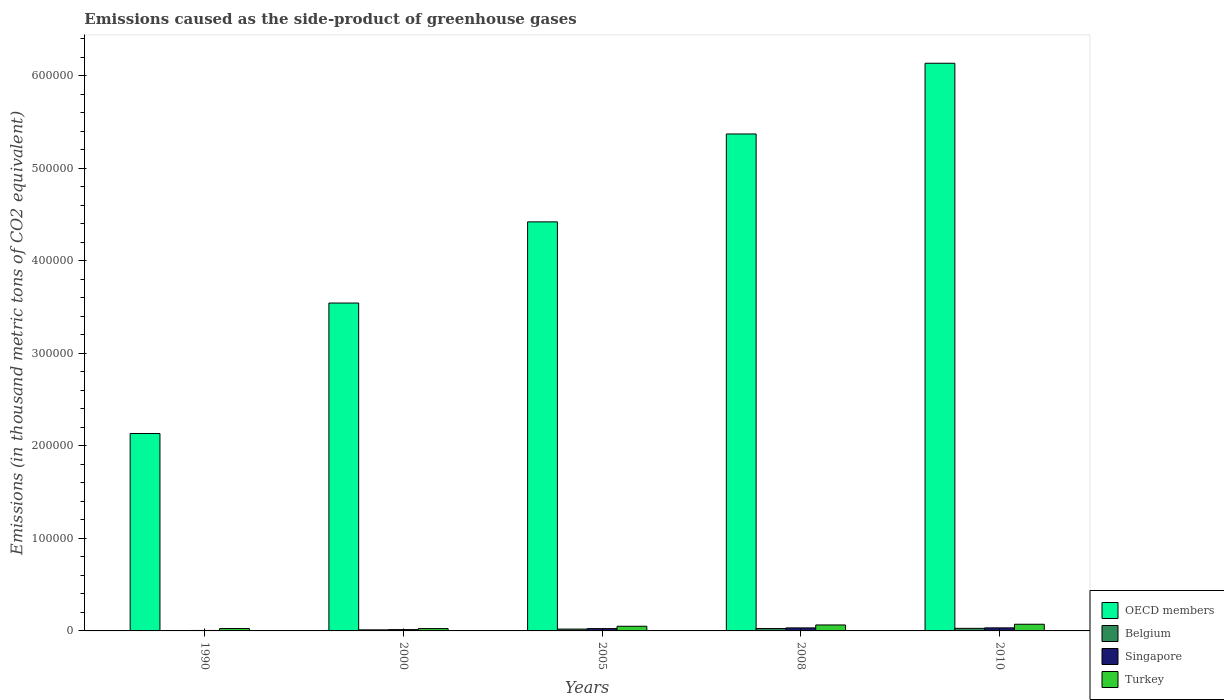How many different coloured bars are there?
Your answer should be very brief. 4. How many groups of bars are there?
Offer a terse response. 5. Are the number of bars on each tick of the X-axis equal?
Your answer should be compact. Yes. How many bars are there on the 5th tick from the left?
Keep it short and to the point. 4. How many bars are there on the 1st tick from the right?
Your answer should be very brief. 4. In how many cases, is the number of bars for a given year not equal to the number of legend labels?
Keep it short and to the point. 0. What is the emissions caused as the side-product of greenhouse gases in Singapore in 2008?
Provide a short and direct response. 3266.4. Across all years, what is the maximum emissions caused as the side-product of greenhouse gases in Singapore?
Offer a terse response. 3296. Across all years, what is the minimum emissions caused as the side-product of greenhouse gases in OECD members?
Keep it short and to the point. 2.13e+05. In which year was the emissions caused as the side-product of greenhouse gases in Belgium maximum?
Provide a succinct answer. 2010. In which year was the emissions caused as the side-product of greenhouse gases in Singapore minimum?
Offer a very short reply. 1990. What is the total emissions caused as the side-product of greenhouse gases in Belgium in the graph?
Offer a very short reply. 8631.7. What is the difference between the emissions caused as the side-product of greenhouse gases in Belgium in 2005 and that in 2010?
Make the answer very short. -794.8. What is the difference between the emissions caused as the side-product of greenhouse gases in Turkey in 2005 and the emissions caused as the side-product of greenhouse gases in Singapore in 1990?
Offer a very short reply. 4539.8. What is the average emissions caused as the side-product of greenhouse gases in OECD members per year?
Provide a short and direct response. 4.32e+05. In the year 2005, what is the difference between the emissions caused as the side-product of greenhouse gases in Turkey and emissions caused as the side-product of greenhouse gases in OECD members?
Make the answer very short. -4.37e+05. In how many years, is the emissions caused as the side-product of greenhouse gases in Turkey greater than 80000 thousand metric tons?
Ensure brevity in your answer.  0. What is the ratio of the emissions caused as the side-product of greenhouse gases in Turkey in 2008 to that in 2010?
Offer a very short reply. 0.89. Is the difference between the emissions caused as the side-product of greenhouse gases in Turkey in 2005 and 2010 greater than the difference between the emissions caused as the side-product of greenhouse gases in OECD members in 2005 and 2010?
Offer a terse response. Yes. What is the difference between the highest and the second highest emissions caused as the side-product of greenhouse gases in Turkey?
Your answer should be very brief. 775. What is the difference between the highest and the lowest emissions caused as the side-product of greenhouse gases in Belgium?
Your response must be concise. 2634.1. In how many years, is the emissions caused as the side-product of greenhouse gases in Turkey greater than the average emissions caused as the side-product of greenhouse gases in Turkey taken over all years?
Your answer should be compact. 3. Is the sum of the emissions caused as the side-product of greenhouse gases in Turkey in 2000 and 2008 greater than the maximum emissions caused as the side-product of greenhouse gases in Belgium across all years?
Offer a terse response. Yes. What does the 2nd bar from the left in 2005 represents?
Ensure brevity in your answer.  Belgium. What does the 3rd bar from the right in 2000 represents?
Provide a succinct answer. Belgium. How many years are there in the graph?
Keep it short and to the point. 5. What is the difference between two consecutive major ticks on the Y-axis?
Your answer should be very brief. 1.00e+05. Are the values on the major ticks of Y-axis written in scientific E-notation?
Your answer should be compact. No. Does the graph contain any zero values?
Make the answer very short. No. How are the legend labels stacked?
Offer a very short reply. Vertical. What is the title of the graph?
Your response must be concise. Emissions caused as the side-product of greenhouse gases. Does "Low income" appear as one of the legend labels in the graph?
Offer a very short reply. No. What is the label or title of the Y-axis?
Offer a terse response. Emissions (in thousand metric tons of CO2 equivalent). What is the Emissions (in thousand metric tons of CO2 equivalent) of OECD members in 1990?
Your answer should be very brief. 2.13e+05. What is the Emissions (in thousand metric tons of CO2 equivalent) of Belgium in 1990?
Offer a very short reply. 141.9. What is the Emissions (in thousand metric tons of CO2 equivalent) in Singapore in 1990?
Offer a very short reply. 501.5. What is the Emissions (in thousand metric tons of CO2 equivalent) in Turkey in 1990?
Keep it short and to the point. 2572.7. What is the Emissions (in thousand metric tons of CO2 equivalent) of OECD members in 2000?
Offer a very short reply. 3.54e+05. What is the Emissions (in thousand metric tons of CO2 equivalent) of Belgium in 2000?
Provide a succinct answer. 1154.6. What is the Emissions (in thousand metric tons of CO2 equivalent) in Singapore in 2000?
Your answer should be compact. 1409.6. What is the Emissions (in thousand metric tons of CO2 equivalent) of Turkey in 2000?
Your answer should be very brief. 2538.5. What is the Emissions (in thousand metric tons of CO2 equivalent) in OECD members in 2005?
Keep it short and to the point. 4.42e+05. What is the Emissions (in thousand metric tons of CO2 equivalent) in Belgium in 2005?
Offer a very short reply. 1981.2. What is the Emissions (in thousand metric tons of CO2 equivalent) of Singapore in 2005?
Make the answer very short. 2496.4. What is the Emissions (in thousand metric tons of CO2 equivalent) of Turkey in 2005?
Give a very brief answer. 5041.3. What is the Emissions (in thousand metric tons of CO2 equivalent) of OECD members in 2008?
Your answer should be very brief. 5.37e+05. What is the Emissions (in thousand metric tons of CO2 equivalent) of Belgium in 2008?
Offer a terse response. 2578. What is the Emissions (in thousand metric tons of CO2 equivalent) of Singapore in 2008?
Keep it short and to the point. 3266.4. What is the Emissions (in thousand metric tons of CO2 equivalent) in Turkey in 2008?
Ensure brevity in your answer.  6441. What is the Emissions (in thousand metric tons of CO2 equivalent) in OECD members in 2010?
Make the answer very short. 6.14e+05. What is the Emissions (in thousand metric tons of CO2 equivalent) in Belgium in 2010?
Make the answer very short. 2776. What is the Emissions (in thousand metric tons of CO2 equivalent) in Singapore in 2010?
Provide a short and direct response. 3296. What is the Emissions (in thousand metric tons of CO2 equivalent) of Turkey in 2010?
Offer a very short reply. 7216. Across all years, what is the maximum Emissions (in thousand metric tons of CO2 equivalent) of OECD members?
Your answer should be compact. 6.14e+05. Across all years, what is the maximum Emissions (in thousand metric tons of CO2 equivalent) in Belgium?
Provide a short and direct response. 2776. Across all years, what is the maximum Emissions (in thousand metric tons of CO2 equivalent) in Singapore?
Provide a succinct answer. 3296. Across all years, what is the maximum Emissions (in thousand metric tons of CO2 equivalent) in Turkey?
Make the answer very short. 7216. Across all years, what is the minimum Emissions (in thousand metric tons of CO2 equivalent) in OECD members?
Provide a short and direct response. 2.13e+05. Across all years, what is the minimum Emissions (in thousand metric tons of CO2 equivalent) of Belgium?
Your answer should be very brief. 141.9. Across all years, what is the minimum Emissions (in thousand metric tons of CO2 equivalent) in Singapore?
Provide a short and direct response. 501.5. Across all years, what is the minimum Emissions (in thousand metric tons of CO2 equivalent) of Turkey?
Provide a short and direct response. 2538.5. What is the total Emissions (in thousand metric tons of CO2 equivalent) of OECD members in the graph?
Keep it short and to the point. 2.16e+06. What is the total Emissions (in thousand metric tons of CO2 equivalent) in Belgium in the graph?
Offer a very short reply. 8631.7. What is the total Emissions (in thousand metric tons of CO2 equivalent) in Singapore in the graph?
Make the answer very short. 1.10e+04. What is the total Emissions (in thousand metric tons of CO2 equivalent) of Turkey in the graph?
Provide a succinct answer. 2.38e+04. What is the difference between the Emissions (in thousand metric tons of CO2 equivalent) in OECD members in 1990 and that in 2000?
Keep it short and to the point. -1.41e+05. What is the difference between the Emissions (in thousand metric tons of CO2 equivalent) in Belgium in 1990 and that in 2000?
Offer a terse response. -1012.7. What is the difference between the Emissions (in thousand metric tons of CO2 equivalent) in Singapore in 1990 and that in 2000?
Ensure brevity in your answer.  -908.1. What is the difference between the Emissions (in thousand metric tons of CO2 equivalent) of Turkey in 1990 and that in 2000?
Provide a short and direct response. 34.2. What is the difference between the Emissions (in thousand metric tons of CO2 equivalent) of OECD members in 1990 and that in 2005?
Ensure brevity in your answer.  -2.29e+05. What is the difference between the Emissions (in thousand metric tons of CO2 equivalent) of Belgium in 1990 and that in 2005?
Your answer should be compact. -1839.3. What is the difference between the Emissions (in thousand metric tons of CO2 equivalent) of Singapore in 1990 and that in 2005?
Keep it short and to the point. -1994.9. What is the difference between the Emissions (in thousand metric tons of CO2 equivalent) in Turkey in 1990 and that in 2005?
Offer a terse response. -2468.6. What is the difference between the Emissions (in thousand metric tons of CO2 equivalent) in OECD members in 1990 and that in 2008?
Make the answer very short. -3.24e+05. What is the difference between the Emissions (in thousand metric tons of CO2 equivalent) of Belgium in 1990 and that in 2008?
Offer a very short reply. -2436.1. What is the difference between the Emissions (in thousand metric tons of CO2 equivalent) in Singapore in 1990 and that in 2008?
Your answer should be very brief. -2764.9. What is the difference between the Emissions (in thousand metric tons of CO2 equivalent) in Turkey in 1990 and that in 2008?
Provide a short and direct response. -3868.3. What is the difference between the Emissions (in thousand metric tons of CO2 equivalent) in OECD members in 1990 and that in 2010?
Offer a terse response. -4.00e+05. What is the difference between the Emissions (in thousand metric tons of CO2 equivalent) of Belgium in 1990 and that in 2010?
Ensure brevity in your answer.  -2634.1. What is the difference between the Emissions (in thousand metric tons of CO2 equivalent) of Singapore in 1990 and that in 2010?
Your answer should be very brief. -2794.5. What is the difference between the Emissions (in thousand metric tons of CO2 equivalent) in Turkey in 1990 and that in 2010?
Offer a very short reply. -4643.3. What is the difference between the Emissions (in thousand metric tons of CO2 equivalent) of OECD members in 2000 and that in 2005?
Make the answer very short. -8.78e+04. What is the difference between the Emissions (in thousand metric tons of CO2 equivalent) of Belgium in 2000 and that in 2005?
Provide a short and direct response. -826.6. What is the difference between the Emissions (in thousand metric tons of CO2 equivalent) in Singapore in 2000 and that in 2005?
Offer a very short reply. -1086.8. What is the difference between the Emissions (in thousand metric tons of CO2 equivalent) of Turkey in 2000 and that in 2005?
Ensure brevity in your answer.  -2502.8. What is the difference between the Emissions (in thousand metric tons of CO2 equivalent) of OECD members in 2000 and that in 2008?
Give a very brief answer. -1.83e+05. What is the difference between the Emissions (in thousand metric tons of CO2 equivalent) in Belgium in 2000 and that in 2008?
Give a very brief answer. -1423.4. What is the difference between the Emissions (in thousand metric tons of CO2 equivalent) in Singapore in 2000 and that in 2008?
Your response must be concise. -1856.8. What is the difference between the Emissions (in thousand metric tons of CO2 equivalent) of Turkey in 2000 and that in 2008?
Your response must be concise. -3902.5. What is the difference between the Emissions (in thousand metric tons of CO2 equivalent) in OECD members in 2000 and that in 2010?
Your response must be concise. -2.59e+05. What is the difference between the Emissions (in thousand metric tons of CO2 equivalent) in Belgium in 2000 and that in 2010?
Keep it short and to the point. -1621.4. What is the difference between the Emissions (in thousand metric tons of CO2 equivalent) in Singapore in 2000 and that in 2010?
Give a very brief answer. -1886.4. What is the difference between the Emissions (in thousand metric tons of CO2 equivalent) of Turkey in 2000 and that in 2010?
Your response must be concise. -4677.5. What is the difference between the Emissions (in thousand metric tons of CO2 equivalent) in OECD members in 2005 and that in 2008?
Make the answer very short. -9.50e+04. What is the difference between the Emissions (in thousand metric tons of CO2 equivalent) of Belgium in 2005 and that in 2008?
Keep it short and to the point. -596.8. What is the difference between the Emissions (in thousand metric tons of CO2 equivalent) in Singapore in 2005 and that in 2008?
Your answer should be compact. -770. What is the difference between the Emissions (in thousand metric tons of CO2 equivalent) of Turkey in 2005 and that in 2008?
Ensure brevity in your answer.  -1399.7. What is the difference between the Emissions (in thousand metric tons of CO2 equivalent) in OECD members in 2005 and that in 2010?
Provide a succinct answer. -1.71e+05. What is the difference between the Emissions (in thousand metric tons of CO2 equivalent) of Belgium in 2005 and that in 2010?
Your answer should be very brief. -794.8. What is the difference between the Emissions (in thousand metric tons of CO2 equivalent) in Singapore in 2005 and that in 2010?
Make the answer very short. -799.6. What is the difference between the Emissions (in thousand metric tons of CO2 equivalent) of Turkey in 2005 and that in 2010?
Provide a short and direct response. -2174.7. What is the difference between the Emissions (in thousand metric tons of CO2 equivalent) in OECD members in 2008 and that in 2010?
Give a very brief answer. -7.65e+04. What is the difference between the Emissions (in thousand metric tons of CO2 equivalent) of Belgium in 2008 and that in 2010?
Keep it short and to the point. -198. What is the difference between the Emissions (in thousand metric tons of CO2 equivalent) in Singapore in 2008 and that in 2010?
Offer a very short reply. -29.6. What is the difference between the Emissions (in thousand metric tons of CO2 equivalent) of Turkey in 2008 and that in 2010?
Your answer should be compact. -775. What is the difference between the Emissions (in thousand metric tons of CO2 equivalent) of OECD members in 1990 and the Emissions (in thousand metric tons of CO2 equivalent) of Belgium in 2000?
Offer a very short reply. 2.12e+05. What is the difference between the Emissions (in thousand metric tons of CO2 equivalent) in OECD members in 1990 and the Emissions (in thousand metric tons of CO2 equivalent) in Singapore in 2000?
Offer a terse response. 2.12e+05. What is the difference between the Emissions (in thousand metric tons of CO2 equivalent) in OECD members in 1990 and the Emissions (in thousand metric tons of CO2 equivalent) in Turkey in 2000?
Offer a terse response. 2.11e+05. What is the difference between the Emissions (in thousand metric tons of CO2 equivalent) in Belgium in 1990 and the Emissions (in thousand metric tons of CO2 equivalent) in Singapore in 2000?
Offer a terse response. -1267.7. What is the difference between the Emissions (in thousand metric tons of CO2 equivalent) in Belgium in 1990 and the Emissions (in thousand metric tons of CO2 equivalent) in Turkey in 2000?
Offer a terse response. -2396.6. What is the difference between the Emissions (in thousand metric tons of CO2 equivalent) of Singapore in 1990 and the Emissions (in thousand metric tons of CO2 equivalent) of Turkey in 2000?
Ensure brevity in your answer.  -2037. What is the difference between the Emissions (in thousand metric tons of CO2 equivalent) in OECD members in 1990 and the Emissions (in thousand metric tons of CO2 equivalent) in Belgium in 2005?
Provide a succinct answer. 2.11e+05. What is the difference between the Emissions (in thousand metric tons of CO2 equivalent) of OECD members in 1990 and the Emissions (in thousand metric tons of CO2 equivalent) of Singapore in 2005?
Give a very brief answer. 2.11e+05. What is the difference between the Emissions (in thousand metric tons of CO2 equivalent) in OECD members in 1990 and the Emissions (in thousand metric tons of CO2 equivalent) in Turkey in 2005?
Your response must be concise. 2.08e+05. What is the difference between the Emissions (in thousand metric tons of CO2 equivalent) in Belgium in 1990 and the Emissions (in thousand metric tons of CO2 equivalent) in Singapore in 2005?
Give a very brief answer. -2354.5. What is the difference between the Emissions (in thousand metric tons of CO2 equivalent) in Belgium in 1990 and the Emissions (in thousand metric tons of CO2 equivalent) in Turkey in 2005?
Make the answer very short. -4899.4. What is the difference between the Emissions (in thousand metric tons of CO2 equivalent) of Singapore in 1990 and the Emissions (in thousand metric tons of CO2 equivalent) of Turkey in 2005?
Give a very brief answer. -4539.8. What is the difference between the Emissions (in thousand metric tons of CO2 equivalent) of OECD members in 1990 and the Emissions (in thousand metric tons of CO2 equivalent) of Belgium in 2008?
Offer a very short reply. 2.11e+05. What is the difference between the Emissions (in thousand metric tons of CO2 equivalent) of OECD members in 1990 and the Emissions (in thousand metric tons of CO2 equivalent) of Singapore in 2008?
Your answer should be very brief. 2.10e+05. What is the difference between the Emissions (in thousand metric tons of CO2 equivalent) of OECD members in 1990 and the Emissions (in thousand metric tons of CO2 equivalent) of Turkey in 2008?
Keep it short and to the point. 2.07e+05. What is the difference between the Emissions (in thousand metric tons of CO2 equivalent) of Belgium in 1990 and the Emissions (in thousand metric tons of CO2 equivalent) of Singapore in 2008?
Provide a succinct answer. -3124.5. What is the difference between the Emissions (in thousand metric tons of CO2 equivalent) of Belgium in 1990 and the Emissions (in thousand metric tons of CO2 equivalent) of Turkey in 2008?
Provide a short and direct response. -6299.1. What is the difference between the Emissions (in thousand metric tons of CO2 equivalent) in Singapore in 1990 and the Emissions (in thousand metric tons of CO2 equivalent) in Turkey in 2008?
Make the answer very short. -5939.5. What is the difference between the Emissions (in thousand metric tons of CO2 equivalent) of OECD members in 1990 and the Emissions (in thousand metric tons of CO2 equivalent) of Belgium in 2010?
Offer a very short reply. 2.11e+05. What is the difference between the Emissions (in thousand metric tons of CO2 equivalent) in OECD members in 1990 and the Emissions (in thousand metric tons of CO2 equivalent) in Singapore in 2010?
Your answer should be very brief. 2.10e+05. What is the difference between the Emissions (in thousand metric tons of CO2 equivalent) of OECD members in 1990 and the Emissions (in thousand metric tons of CO2 equivalent) of Turkey in 2010?
Your answer should be compact. 2.06e+05. What is the difference between the Emissions (in thousand metric tons of CO2 equivalent) in Belgium in 1990 and the Emissions (in thousand metric tons of CO2 equivalent) in Singapore in 2010?
Your answer should be compact. -3154.1. What is the difference between the Emissions (in thousand metric tons of CO2 equivalent) of Belgium in 1990 and the Emissions (in thousand metric tons of CO2 equivalent) of Turkey in 2010?
Give a very brief answer. -7074.1. What is the difference between the Emissions (in thousand metric tons of CO2 equivalent) of Singapore in 1990 and the Emissions (in thousand metric tons of CO2 equivalent) of Turkey in 2010?
Ensure brevity in your answer.  -6714.5. What is the difference between the Emissions (in thousand metric tons of CO2 equivalent) in OECD members in 2000 and the Emissions (in thousand metric tons of CO2 equivalent) in Belgium in 2005?
Offer a very short reply. 3.53e+05. What is the difference between the Emissions (in thousand metric tons of CO2 equivalent) in OECD members in 2000 and the Emissions (in thousand metric tons of CO2 equivalent) in Singapore in 2005?
Offer a very short reply. 3.52e+05. What is the difference between the Emissions (in thousand metric tons of CO2 equivalent) in OECD members in 2000 and the Emissions (in thousand metric tons of CO2 equivalent) in Turkey in 2005?
Give a very brief answer. 3.49e+05. What is the difference between the Emissions (in thousand metric tons of CO2 equivalent) of Belgium in 2000 and the Emissions (in thousand metric tons of CO2 equivalent) of Singapore in 2005?
Make the answer very short. -1341.8. What is the difference between the Emissions (in thousand metric tons of CO2 equivalent) of Belgium in 2000 and the Emissions (in thousand metric tons of CO2 equivalent) of Turkey in 2005?
Make the answer very short. -3886.7. What is the difference between the Emissions (in thousand metric tons of CO2 equivalent) in Singapore in 2000 and the Emissions (in thousand metric tons of CO2 equivalent) in Turkey in 2005?
Provide a succinct answer. -3631.7. What is the difference between the Emissions (in thousand metric tons of CO2 equivalent) of OECD members in 2000 and the Emissions (in thousand metric tons of CO2 equivalent) of Belgium in 2008?
Offer a terse response. 3.52e+05. What is the difference between the Emissions (in thousand metric tons of CO2 equivalent) in OECD members in 2000 and the Emissions (in thousand metric tons of CO2 equivalent) in Singapore in 2008?
Offer a terse response. 3.51e+05. What is the difference between the Emissions (in thousand metric tons of CO2 equivalent) in OECD members in 2000 and the Emissions (in thousand metric tons of CO2 equivalent) in Turkey in 2008?
Offer a terse response. 3.48e+05. What is the difference between the Emissions (in thousand metric tons of CO2 equivalent) in Belgium in 2000 and the Emissions (in thousand metric tons of CO2 equivalent) in Singapore in 2008?
Offer a very short reply. -2111.8. What is the difference between the Emissions (in thousand metric tons of CO2 equivalent) of Belgium in 2000 and the Emissions (in thousand metric tons of CO2 equivalent) of Turkey in 2008?
Your answer should be compact. -5286.4. What is the difference between the Emissions (in thousand metric tons of CO2 equivalent) in Singapore in 2000 and the Emissions (in thousand metric tons of CO2 equivalent) in Turkey in 2008?
Your answer should be compact. -5031.4. What is the difference between the Emissions (in thousand metric tons of CO2 equivalent) of OECD members in 2000 and the Emissions (in thousand metric tons of CO2 equivalent) of Belgium in 2010?
Ensure brevity in your answer.  3.52e+05. What is the difference between the Emissions (in thousand metric tons of CO2 equivalent) of OECD members in 2000 and the Emissions (in thousand metric tons of CO2 equivalent) of Singapore in 2010?
Give a very brief answer. 3.51e+05. What is the difference between the Emissions (in thousand metric tons of CO2 equivalent) of OECD members in 2000 and the Emissions (in thousand metric tons of CO2 equivalent) of Turkey in 2010?
Make the answer very short. 3.47e+05. What is the difference between the Emissions (in thousand metric tons of CO2 equivalent) in Belgium in 2000 and the Emissions (in thousand metric tons of CO2 equivalent) in Singapore in 2010?
Your answer should be very brief. -2141.4. What is the difference between the Emissions (in thousand metric tons of CO2 equivalent) of Belgium in 2000 and the Emissions (in thousand metric tons of CO2 equivalent) of Turkey in 2010?
Keep it short and to the point. -6061.4. What is the difference between the Emissions (in thousand metric tons of CO2 equivalent) of Singapore in 2000 and the Emissions (in thousand metric tons of CO2 equivalent) of Turkey in 2010?
Provide a short and direct response. -5806.4. What is the difference between the Emissions (in thousand metric tons of CO2 equivalent) in OECD members in 2005 and the Emissions (in thousand metric tons of CO2 equivalent) in Belgium in 2008?
Make the answer very short. 4.40e+05. What is the difference between the Emissions (in thousand metric tons of CO2 equivalent) of OECD members in 2005 and the Emissions (in thousand metric tons of CO2 equivalent) of Singapore in 2008?
Keep it short and to the point. 4.39e+05. What is the difference between the Emissions (in thousand metric tons of CO2 equivalent) of OECD members in 2005 and the Emissions (in thousand metric tons of CO2 equivalent) of Turkey in 2008?
Offer a terse response. 4.36e+05. What is the difference between the Emissions (in thousand metric tons of CO2 equivalent) of Belgium in 2005 and the Emissions (in thousand metric tons of CO2 equivalent) of Singapore in 2008?
Your answer should be compact. -1285.2. What is the difference between the Emissions (in thousand metric tons of CO2 equivalent) in Belgium in 2005 and the Emissions (in thousand metric tons of CO2 equivalent) in Turkey in 2008?
Provide a succinct answer. -4459.8. What is the difference between the Emissions (in thousand metric tons of CO2 equivalent) of Singapore in 2005 and the Emissions (in thousand metric tons of CO2 equivalent) of Turkey in 2008?
Your answer should be very brief. -3944.6. What is the difference between the Emissions (in thousand metric tons of CO2 equivalent) in OECD members in 2005 and the Emissions (in thousand metric tons of CO2 equivalent) in Belgium in 2010?
Your response must be concise. 4.39e+05. What is the difference between the Emissions (in thousand metric tons of CO2 equivalent) of OECD members in 2005 and the Emissions (in thousand metric tons of CO2 equivalent) of Singapore in 2010?
Make the answer very short. 4.39e+05. What is the difference between the Emissions (in thousand metric tons of CO2 equivalent) in OECD members in 2005 and the Emissions (in thousand metric tons of CO2 equivalent) in Turkey in 2010?
Keep it short and to the point. 4.35e+05. What is the difference between the Emissions (in thousand metric tons of CO2 equivalent) of Belgium in 2005 and the Emissions (in thousand metric tons of CO2 equivalent) of Singapore in 2010?
Keep it short and to the point. -1314.8. What is the difference between the Emissions (in thousand metric tons of CO2 equivalent) in Belgium in 2005 and the Emissions (in thousand metric tons of CO2 equivalent) in Turkey in 2010?
Your answer should be compact. -5234.8. What is the difference between the Emissions (in thousand metric tons of CO2 equivalent) of Singapore in 2005 and the Emissions (in thousand metric tons of CO2 equivalent) of Turkey in 2010?
Provide a succinct answer. -4719.6. What is the difference between the Emissions (in thousand metric tons of CO2 equivalent) in OECD members in 2008 and the Emissions (in thousand metric tons of CO2 equivalent) in Belgium in 2010?
Keep it short and to the point. 5.34e+05. What is the difference between the Emissions (in thousand metric tons of CO2 equivalent) of OECD members in 2008 and the Emissions (in thousand metric tons of CO2 equivalent) of Singapore in 2010?
Ensure brevity in your answer.  5.34e+05. What is the difference between the Emissions (in thousand metric tons of CO2 equivalent) in OECD members in 2008 and the Emissions (in thousand metric tons of CO2 equivalent) in Turkey in 2010?
Provide a succinct answer. 5.30e+05. What is the difference between the Emissions (in thousand metric tons of CO2 equivalent) in Belgium in 2008 and the Emissions (in thousand metric tons of CO2 equivalent) in Singapore in 2010?
Give a very brief answer. -718. What is the difference between the Emissions (in thousand metric tons of CO2 equivalent) in Belgium in 2008 and the Emissions (in thousand metric tons of CO2 equivalent) in Turkey in 2010?
Keep it short and to the point. -4638. What is the difference between the Emissions (in thousand metric tons of CO2 equivalent) of Singapore in 2008 and the Emissions (in thousand metric tons of CO2 equivalent) of Turkey in 2010?
Your answer should be compact. -3949.6. What is the average Emissions (in thousand metric tons of CO2 equivalent) in OECD members per year?
Provide a succinct answer. 4.32e+05. What is the average Emissions (in thousand metric tons of CO2 equivalent) in Belgium per year?
Provide a short and direct response. 1726.34. What is the average Emissions (in thousand metric tons of CO2 equivalent) in Singapore per year?
Offer a terse response. 2193.98. What is the average Emissions (in thousand metric tons of CO2 equivalent) of Turkey per year?
Your answer should be compact. 4761.9. In the year 1990, what is the difference between the Emissions (in thousand metric tons of CO2 equivalent) of OECD members and Emissions (in thousand metric tons of CO2 equivalent) of Belgium?
Keep it short and to the point. 2.13e+05. In the year 1990, what is the difference between the Emissions (in thousand metric tons of CO2 equivalent) in OECD members and Emissions (in thousand metric tons of CO2 equivalent) in Singapore?
Ensure brevity in your answer.  2.13e+05. In the year 1990, what is the difference between the Emissions (in thousand metric tons of CO2 equivalent) in OECD members and Emissions (in thousand metric tons of CO2 equivalent) in Turkey?
Provide a succinct answer. 2.11e+05. In the year 1990, what is the difference between the Emissions (in thousand metric tons of CO2 equivalent) of Belgium and Emissions (in thousand metric tons of CO2 equivalent) of Singapore?
Offer a very short reply. -359.6. In the year 1990, what is the difference between the Emissions (in thousand metric tons of CO2 equivalent) in Belgium and Emissions (in thousand metric tons of CO2 equivalent) in Turkey?
Ensure brevity in your answer.  -2430.8. In the year 1990, what is the difference between the Emissions (in thousand metric tons of CO2 equivalent) of Singapore and Emissions (in thousand metric tons of CO2 equivalent) of Turkey?
Keep it short and to the point. -2071.2. In the year 2000, what is the difference between the Emissions (in thousand metric tons of CO2 equivalent) in OECD members and Emissions (in thousand metric tons of CO2 equivalent) in Belgium?
Provide a succinct answer. 3.53e+05. In the year 2000, what is the difference between the Emissions (in thousand metric tons of CO2 equivalent) of OECD members and Emissions (in thousand metric tons of CO2 equivalent) of Singapore?
Your response must be concise. 3.53e+05. In the year 2000, what is the difference between the Emissions (in thousand metric tons of CO2 equivalent) in OECD members and Emissions (in thousand metric tons of CO2 equivalent) in Turkey?
Offer a very short reply. 3.52e+05. In the year 2000, what is the difference between the Emissions (in thousand metric tons of CO2 equivalent) in Belgium and Emissions (in thousand metric tons of CO2 equivalent) in Singapore?
Provide a short and direct response. -255. In the year 2000, what is the difference between the Emissions (in thousand metric tons of CO2 equivalent) of Belgium and Emissions (in thousand metric tons of CO2 equivalent) of Turkey?
Your answer should be compact. -1383.9. In the year 2000, what is the difference between the Emissions (in thousand metric tons of CO2 equivalent) in Singapore and Emissions (in thousand metric tons of CO2 equivalent) in Turkey?
Offer a very short reply. -1128.9. In the year 2005, what is the difference between the Emissions (in thousand metric tons of CO2 equivalent) of OECD members and Emissions (in thousand metric tons of CO2 equivalent) of Belgium?
Make the answer very short. 4.40e+05. In the year 2005, what is the difference between the Emissions (in thousand metric tons of CO2 equivalent) in OECD members and Emissions (in thousand metric tons of CO2 equivalent) in Singapore?
Keep it short and to the point. 4.40e+05. In the year 2005, what is the difference between the Emissions (in thousand metric tons of CO2 equivalent) in OECD members and Emissions (in thousand metric tons of CO2 equivalent) in Turkey?
Ensure brevity in your answer.  4.37e+05. In the year 2005, what is the difference between the Emissions (in thousand metric tons of CO2 equivalent) in Belgium and Emissions (in thousand metric tons of CO2 equivalent) in Singapore?
Provide a short and direct response. -515.2. In the year 2005, what is the difference between the Emissions (in thousand metric tons of CO2 equivalent) of Belgium and Emissions (in thousand metric tons of CO2 equivalent) of Turkey?
Your answer should be compact. -3060.1. In the year 2005, what is the difference between the Emissions (in thousand metric tons of CO2 equivalent) of Singapore and Emissions (in thousand metric tons of CO2 equivalent) of Turkey?
Provide a short and direct response. -2544.9. In the year 2008, what is the difference between the Emissions (in thousand metric tons of CO2 equivalent) in OECD members and Emissions (in thousand metric tons of CO2 equivalent) in Belgium?
Your response must be concise. 5.35e+05. In the year 2008, what is the difference between the Emissions (in thousand metric tons of CO2 equivalent) in OECD members and Emissions (in thousand metric tons of CO2 equivalent) in Singapore?
Ensure brevity in your answer.  5.34e+05. In the year 2008, what is the difference between the Emissions (in thousand metric tons of CO2 equivalent) in OECD members and Emissions (in thousand metric tons of CO2 equivalent) in Turkey?
Keep it short and to the point. 5.31e+05. In the year 2008, what is the difference between the Emissions (in thousand metric tons of CO2 equivalent) in Belgium and Emissions (in thousand metric tons of CO2 equivalent) in Singapore?
Keep it short and to the point. -688.4. In the year 2008, what is the difference between the Emissions (in thousand metric tons of CO2 equivalent) of Belgium and Emissions (in thousand metric tons of CO2 equivalent) of Turkey?
Your response must be concise. -3863. In the year 2008, what is the difference between the Emissions (in thousand metric tons of CO2 equivalent) in Singapore and Emissions (in thousand metric tons of CO2 equivalent) in Turkey?
Keep it short and to the point. -3174.6. In the year 2010, what is the difference between the Emissions (in thousand metric tons of CO2 equivalent) in OECD members and Emissions (in thousand metric tons of CO2 equivalent) in Belgium?
Your answer should be compact. 6.11e+05. In the year 2010, what is the difference between the Emissions (in thousand metric tons of CO2 equivalent) in OECD members and Emissions (in thousand metric tons of CO2 equivalent) in Singapore?
Your response must be concise. 6.10e+05. In the year 2010, what is the difference between the Emissions (in thousand metric tons of CO2 equivalent) in OECD members and Emissions (in thousand metric tons of CO2 equivalent) in Turkey?
Give a very brief answer. 6.06e+05. In the year 2010, what is the difference between the Emissions (in thousand metric tons of CO2 equivalent) of Belgium and Emissions (in thousand metric tons of CO2 equivalent) of Singapore?
Make the answer very short. -520. In the year 2010, what is the difference between the Emissions (in thousand metric tons of CO2 equivalent) of Belgium and Emissions (in thousand metric tons of CO2 equivalent) of Turkey?
Your answer should be compact. -4440. In the year 2010, what is the difference between the Emissions (in thousand metric tons of CO2 equivalent) of Singapore and Emissions (in thousand metric tons of CO2 equivalent) of Turkey?
Provide a succinct answer. -3920. What is the ratio of the Emissions (in thousand metric tons of CO2 equivalent) of OECD members in 1990 to that in 2000?
Your answer should be very brief. 0.6. What is the ratio of the Emissions (in thousand metric tons of CO2 equivalent) in Belgium in 1990 to that in 2000?
Give a very brief answer. 0.12. What is the ratio of the Emissions (in thousand metric tons of CO2 equivalent) of Singapore in 1990 to that in 2000?
Make the answer very short. 0.36. What is the ratio of the Emissions (in thousand metric tons of CO2 equivalent) in Turkey in 1990 to that in 2000?
Give a very brief answer. 1.01. What is the ratio of the Emissions (in thousand metric tons of CO2 equivalent) of OECD members in 1990 to that in 2005?
Give a very brief answer. 0.48. What is the ratio of the Emissions (in thousand metric tons of CO2 equivalent) of Belgium in 1990 to that in 2005?
Your answer should be compact. 0.07. What is the ratio of the Emissions (in thousand metric tons of CO2 equivalent) of Singapore in 1990 to that in 2005?
Offer a terse response. 0.2. What is the ratio of the Emissions (in thousand metric tons of CO2 equivalent) in Turkey in 1990 to that in 2005?
Make the answer very short. 0.51. What is the ratio of the Emissions (in thousand metric tons of CO2 equivalent) of OECD members in 1990 to that in 2008?
Ensure brevity in your answer.  0.4. What is the ratio of the Emissions (in thousand metric tons of CO2 equivalent) in Belgium in 1990 to that in 2008?
Provide a short and direct response. 0.06. What is the ratio of the Emissions (in thousand metric tons of CO2 equivalent) in Singapore in 1990 to that in 2008?
Your answer should be very brief. 0.15. What is the ratio of the Emissions (in thousand metric tons of CO2 equivalent) in Turkey in 1990 to that in 2008?
Keep it short and to the point. 0.4. What is the ratio of the Emissions (in thousand metric tons of CO2 equivalent) in OECD members in 1990 to that in 2010?
Offer a very short reply. 0.35. What is the ratio of the Emissions (in thousand metric tons of CO2 equivalent) in Belgium in 1990 to that in 2010?
Ensure brevity in your answer.  0.05. What is the ratio of the Emissions (in thousand metric tons of CO2 equivalent) in Singapore in 1990 to that in 2010?
Offer a very short reply. 0.15. What is the ratio of the Emissions (in thousand metric tons of CO2 equivalent) in Turkey in 1990 to that in 2010?
Offer a very short reply. 0.36. What is the ratio of the Emissions (in thousand metric tons of CO2 equivalent) in OECD members in 2000 to that in 2005?
Your answer should be compact. 0.8. What is the ratio of the Emissions (in thousand metric tons of CO2 equivalent) in Belgium in 2000 to that in 2005?
Your answer should be very brief. 0.58. What is the ratio of the Emissions (in thousand metric tons of CO2 equivalent) of Singapore in 2000 to that in 2005?
Provide a short and direct response. 0.56. What is the ratio of the Emissions (in thousand metric tons of CO2 equivalent) of Turkey in 2000 to that in 2005?
Your answer should be very brief. 0.5. What is the ratio of the Emissions (in thousand metric tons of CO2 equivalent) in OECD members in 2000 to that in 2008?
Your answer should be very brief. 0.66. What is the ratio of the Emissions (in thousand metric tons of CO2 equivalent) in Belgium in 2000 to that in 2008?
Keep it short and to the point. 0.45. What is the ratio of the Emissions (in thousand metric tons of CO2 equivalent) of Singapore in 2000 to that in 2008?
Make the answer very short. 0.43. What is the ratio of the Emissions (in thousand metric tons of CO2 equivalent) in Turkey in 2000 to that in 2008?
Offer a terse response. 0.39. What is the ratio of the Emissions (in thousand metric tons of CO2 equivalent) in OECD members in 2000 to that in 2010?
Provide a succinct answer. 0.58. What is the ratio of the Emissions (in thousand metric tons of CO2 equivalent) of Belgium in 2000 to that in 2010?
Offer a terse response. 0.42. What is the ratio of the Emissions (in thousand metric tons of CO2 equivalent) of Singapore in 2000 to that in 2010?
Give a very brief answer. 0.43. What is the ratio of the Emissions (in thousand metric tons of CO2 equivalent) in Turkey in 2000 to that in 2010?
Provide a succinct answer. 0.35. What is the ratio of the Emissions (in thousand metric tons of CO2 equivalent) in OECD members in 2005 to that in 2008?
Your answer should be very brief. 0.82. What is the ratio of the Emissions (in thousand metric tons of CO2 equivalent) of Belgium in 2005 to that in 2008?
Provide a succinct answer. 0.77. What is the ratio of the Emissions (in thousand metric tons of CO2 equivalent) of Singapore in 2005 to that in 2008?
Ensure brevity in your answer.  0.76. What is the ratio of the Emissions (in thousand metric tons of CO2 equivalent) in Turkey in 2005 to that in 2008?
Your response must be concise. 0.78. What is the ratio of the Emissions (in thousand metric tons of CO2 equivalent) in OECD members in 2005 to that in 2010?
Offer a very short reply. 0.72. What is the ratio of the Emissions (in thousand metric tons of CO2 equivalent) of Belgium in 2005 to that in 2010?
Make the answer very short. 0.71. What is the ratio of the Emissions (in thousand metric tons of CO2 equivalent) in Singapore in 2005 to that in 2010?
Offer a very short reply. 0.76. What is the ratio of the Emissions (in thousand metric tons of CO2 equivalent) in Turkey in 2005 to that in 2010?
Offer a terse response. 0.7. What is the ratio of the Emissions (in thousand metric tons of CO2 equivalent) of OECD members in 2008 to that in 2010?
Provide a succinct answer. 0.88. What is the ratio of the Emissions (in thousand metric tons of CO2 equivalent) in Belgium in 2008 to that in 2010?
Provide a short and direct response. 0.93. What is the ratio of the Emissions (in thousand metric tons of CO2 equivalent) of Turkey in 2008 to that in 2010?
Your answer should be compact. 0.89. What is the difference between the highest and the second highest Emissions (in thousand metric tons of CO2 equivalent) in OECD members?
Provide a short and direct response. 7.65e+04. What is the difference between the highest and the second highest Emissions (in thousand metric tons of CO2 equivalent) of Belgium?
Your answer should be very brief. 198. What is the difference between the highest and the second highest Emissions (in thousand metric tons of CO2 equivalent) of Singapore?
Your answer should be very brief. 29.6. What is the difference between the highest and the second highest Emissions (in thousand metric tons of CO2 equivalent) in Turkey?
Provide a succinct answer. 775. What is the difference between the highest and the lowest Emissions (in thousand metric tons of CO2 equivalent) in OECD members?
Offer a terse response. 4.00e+05. What is the difference between the highest and the lowest Emissions (in thousand metric tons of CO2 equivalent) of Belgium?
Make the answer very short. 2634.1. What is the difference between the highest and the lowest Emissions (in thousand metric tons of CO2 equivalent) in Singapore?
Provide a short and direct response. 2794.5. What is the difference between the highest and the lowest Emissions (in thousand metric tons of CO2 equivalent) in Turkey?
Your answer should be compact. 4677.5. 